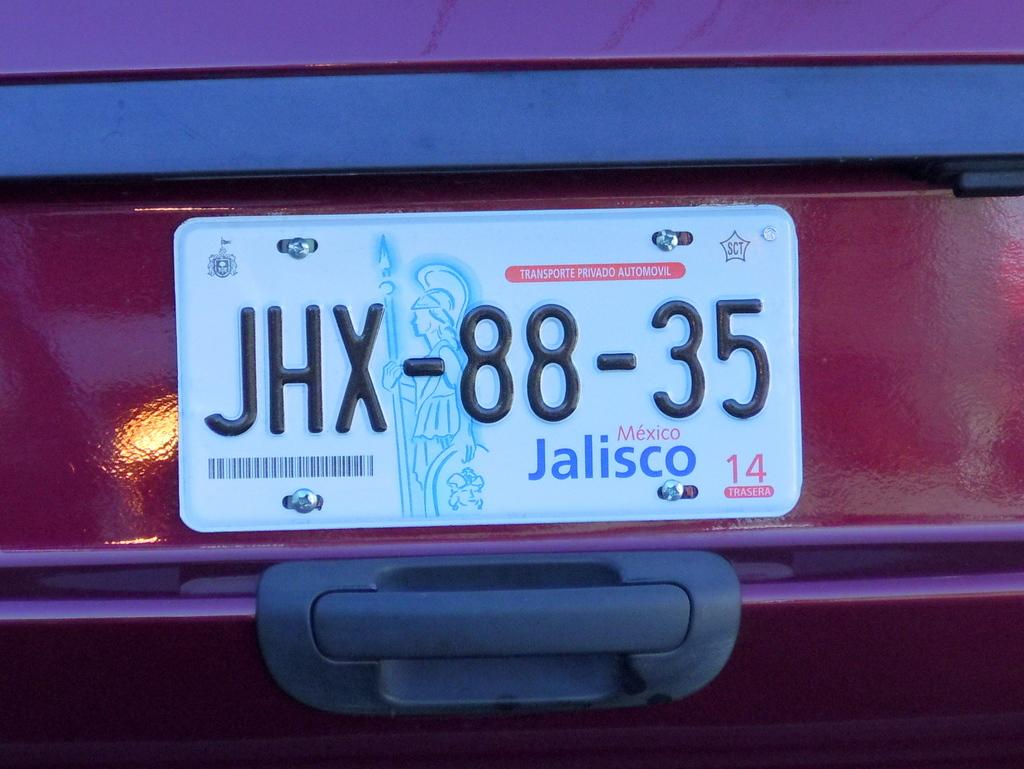Provide a one-sentence caption for the provided image. A car plate from the city of Jalisco, Mexico. 